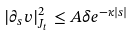Convert formula to latex. <formula><loc_0><loc_0><loc_500><loc_500>| \partial _ { s } v | _ { J _ { t } } ^ { 2 } \leq A \delta e ^ { - \kappa | s | }</formula> 